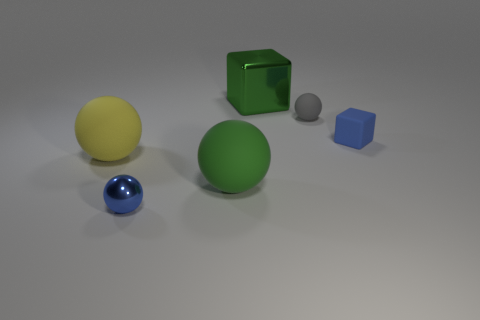The object that is to the left of the blue thing that is on the left side of the gray rubber ball is what shape?
Your answer should be compact. Sphere. What is the shape of the tiny rubber object that is the same color as the small metal sphere?
Make the answer very short. Cube. Is the shape of the small blue thing on the right side of the small blue sphere the same as  the tiny metal thing?
Give a very brief answer. No. What is the shape of the shiny object in front of the gray matte sphere?
Provide a succinct answer. Sphere. Is the color of the large metal block the same as the big sphere that is to the right of the small shiny sphere?
Give a very brief answer. Yes. Do the yellow sphere and the blue object on the left side of the green cube have the same material?
Give a very brief answer. No. There is a sphere that is the same size as the gray thing; what is its material?
Offer a very short reply. Metal. There is a blue thing that is on the left side of the rubber cube; how big is it?
Ensure brevity in your answer.  Small. Does the block that is in front of the small gray rubber sphere have the same size as the metal thing that is to the left of the green rubber sphere?
Your answer should be compact. Yes. What number of spheres are the same material as the blue block?
Your answer should be compact. 3. 